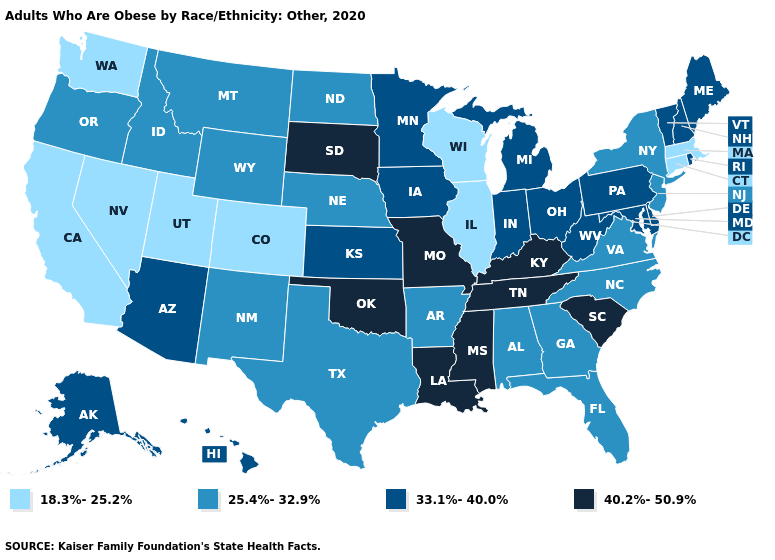Is the legend a continuous bar?
Short answer required. No. What is the highest value in the MidWest ?
Answer briefly. 40.2%-50.9%. What is the value of Colorado?
Write a very short answer. 18.3%-25.2%. What is the highest value in the MidWest ?
Short answer required. 40.2%-50.9%. What is the lowest value in the Northeast?
Quick response, please. 18.3%-25.2%. Is the legend a continuous bar?
Quick response, please. No. What is the value of Arizona?
Be succinct. 33.1%-40.0%. Does Colorado have the highest value in the West?
Quick response, please. No. Which states have the lowest value in the USA?
Be succinct. California, Colorado, Connecticut, Illinois, Massachusetts, Nevada, Utah, Washington, Wisconsin. Does Maryland have a lower value than Kansas?
Quick response, please. No. What is the value of Pennsylvania?
Quick response, please. 33.1%-40.0%. What is the value of Iowa?
Answer briefly. 33.1%-40.0%. What is the highest value in the USA?
Write a very short answer. 40.2%-50.9%. Among the states that border Wyoming , does South Dakota have the highest value?
Short answer required. Yes. Does California have the highest value in the USA?
Short answer required. No. 